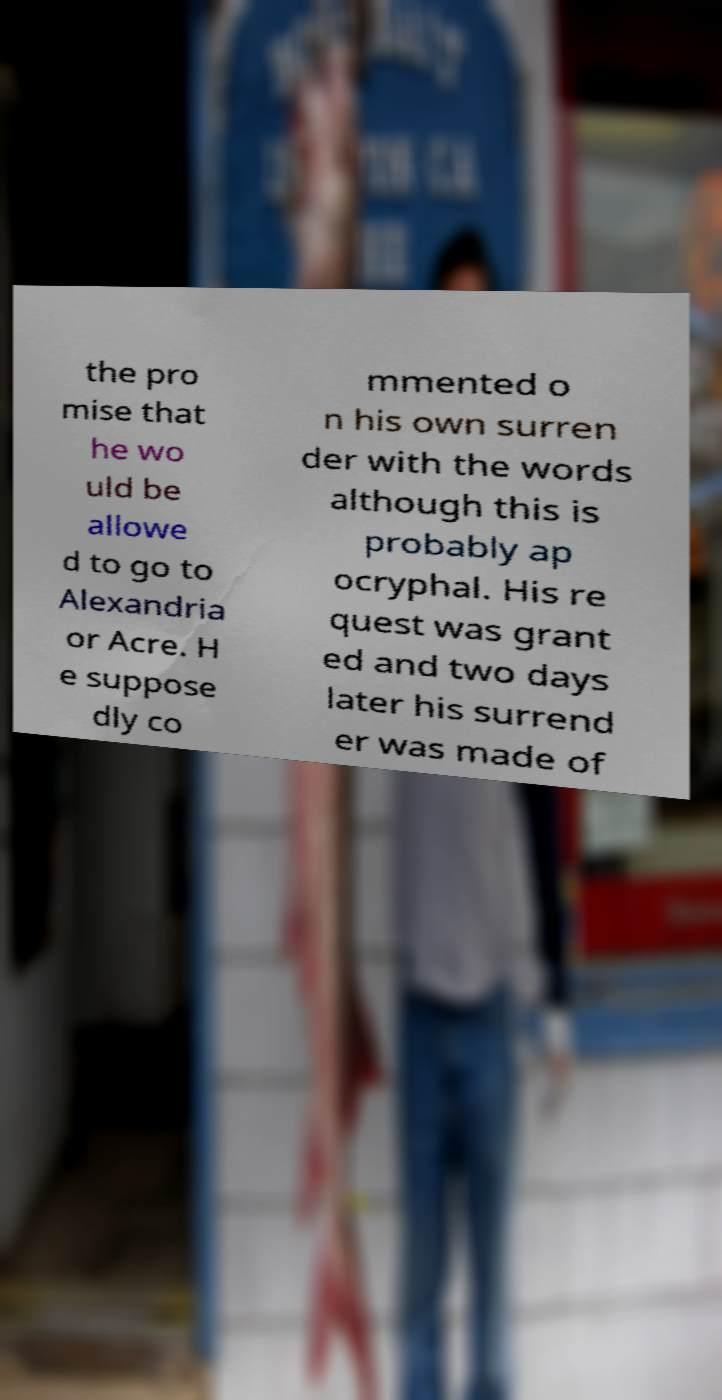What messages or text are displayed in this image? I need them in a readable, typed format. the pro mise that he wo uld be allowe d to go to Alexandria or Acre. H e suppose dly co mmented o n his own surren der with the words although this is probably ap ocryphal. His re quest was grant ed and two days later his surrend er was made of 